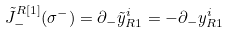<formula> <loc_0><loc_0><loc_500><loc_500>\tilde { J } _ { - } ^ { R [ 1 ] } ( \sigma ^ { - } ) = \partial _ { - } \tilde { y } _ { R 1 } ^ { i } = - \partial _ { - } y _ { R 1 } ^ { i }</formula> 